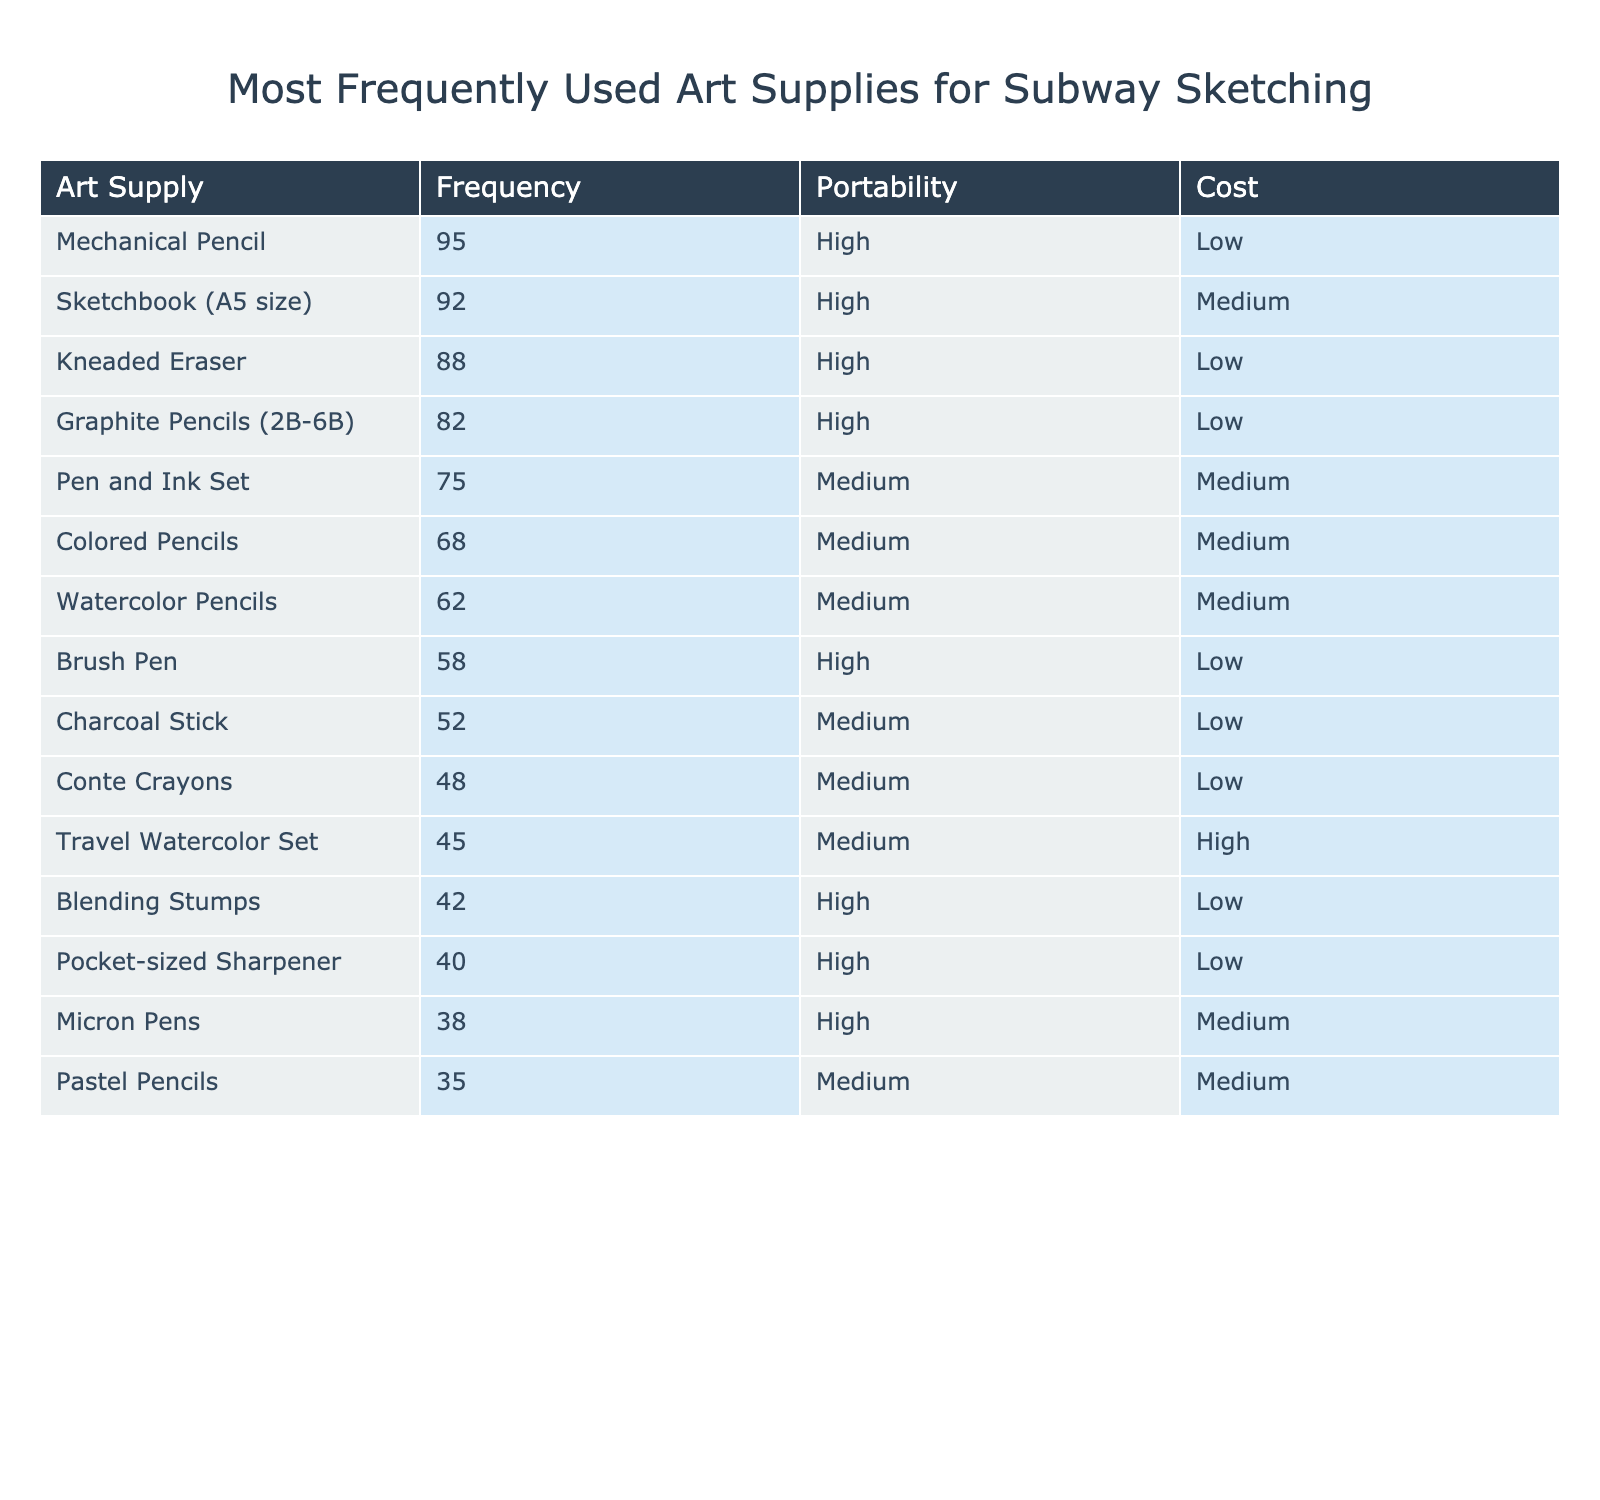What is the most frequently used art supply for subway sketching? The table shows the "Frequency" column, which indicates how often each art supply is used. The highest frequency is 95 for the Mechanical Pencil.
Answer: Mechanical Pencil What is the frequency of the Sketchbook (A5 size)? By checking the frequency column for Sketchbook (A5 size), it is listed as 92.
Answer: 92 Which art supply has the lowest frequency of use? The lowest frequency in the table is found in the Pastel Pencils, which has a frequency of 35.
Answer: Pastel Pencils Is the Kneaded Eraser considered a portable art supply? The table indicates that the Kneaded Eraser has a "Portability" rating of High, making it portable.
Answer: Yes What is the average frequency of the top three art supplies? The top three art supplies, their frequencies are 95 (Mechanical Pencil), 92 (Sketchbook A5 size), and 88 (Kneaded Eraser). Adding them gives 275, and dividing by 3 gives an average frequency of 91.67.
Answer: 91.67 How many art supplies have a high portability rating? Counting the "Portability" column, we see 7 art supplies marked as High portability (Mechanical Pencil, Sketchbook A5 size, Kneaded Eraser, Graphite Pencils, Brush Pen, Blending Stumps, and Pocket-sized Sharpener).
Answer: 7 What is the cost category of the Travel Watercolor Set? The "Cost" column shows the Travel Watercolor Set is categorized as High.
Answer: High Are more art supplies categorized as Low cost or Medium cost? By checking the "Cost" column, there are 7 art supplies at Low cost (Mechanical Pencil, Kneaded Eraser, Graphite Pencils, Brush Pen, Charcoal Stick, Conte Crayons, Blending Stumps, and Pocket-sized Sharpener) and 6 at Medium cost. Therefore, Low cost has more entries.
Answer: Low cost What is the total frequency of art supplies that have a Medium portability rating? The art supplies with Medium portability (Pen and Ink Set, Colored Pencils, Watercolor Pencils, Charcoal Stick, Conte Crayons, Travel Watercolor Set, and Pastel Pencils) have frequencies of 75, 68, 62, 52, 48, 45, and 35 respectively. Their total frequency sums up to 405.
Answer: 405 Identify the art supply with the highest cost that has a Medium portability rating. The "Cost" column shows that the Travel Watercolor Set is categorized as Medium, and has the highest frequency among the Medium portability category. Its cost is also categorized as High. Therefore, it fits the criteria.
Answer: Travel Watercolor Set 